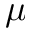<formula> <loc_0><loc_0><loc_500><loc_500>\mu</formula> 